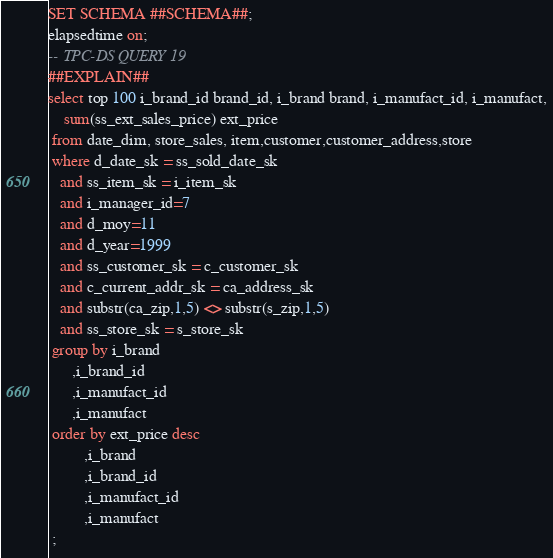Convert code to text. <code><loc_0><loc_0><loc_500><loc_500><_SQL_>SET SCHEMA ##SCHEMA##;
elapsedtime on;
-- TPC-DS QUERY 19
##EXPLAIN##
select top 100 i_brand_id brand_id, i_brand brand, i_manufact_id, i_manufact,
 	sum(ss_ext_sales_price) ext_price
 from date_dim, store_sales, item,customer,customer_address,store
 where d_date_sk = ss_sold_date_sk
   and ss_item_sk = i_item_sk
   and i_manager_id=7
   and d_moy=11
   and d_year=1999
   and ss_customer_sk = c_customer_sk 
   and c_current_addr_sk = ca_address_sk
   and substr(ca_zip,1,5) <> substr(s_zip,1,5) 
   and ss_store_sk = s_store_sk 
 group by i_brand
      ,i_brand_id
      ,i_manufact_id
      ,i_manufact
 order by ext_price desc
         ,i_brand
         ,i_brand_id
         ,i_manufact_id
         ,i_manufact
 ;
</code> 